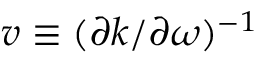Convert formula to latex. <formula><loc_0><loc_0><loc_500><loc_500>v \equiv ( \partial k / \partial \omega ) ^ { - 1 }</formula> 